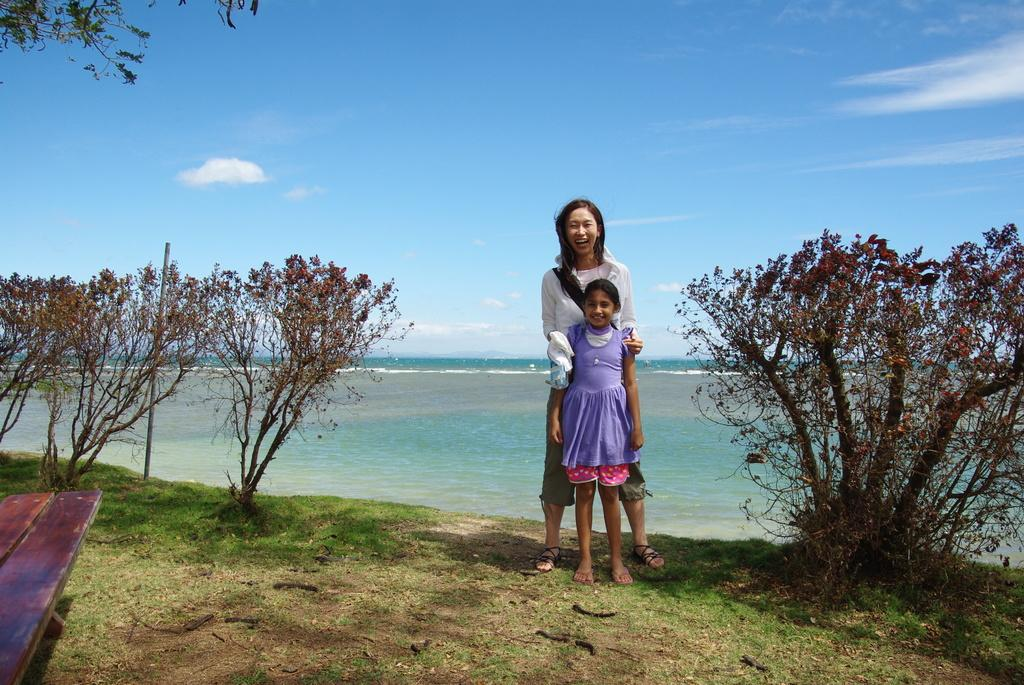Who is present in the image? There is a woman and a girl in the image. What are the woman and the girl doing in the image? Both the woman and the girl are standing on the ground and smiling. What can be seen in the background of the image? There are trees, a bench, grass, water, and the sky visible in the background of the image. What is the condition of the sky in the image? The sky is visible in the background of the image, and there are clouds present. Can you tell me what type of receipt the woman is holding in the image? There is no receipt present in the image; the woman and the girl are simply standing and smiling. What kind of art can be seen on the girl's face in the image? There is no art or face paint visible on the girl's face in the image. 